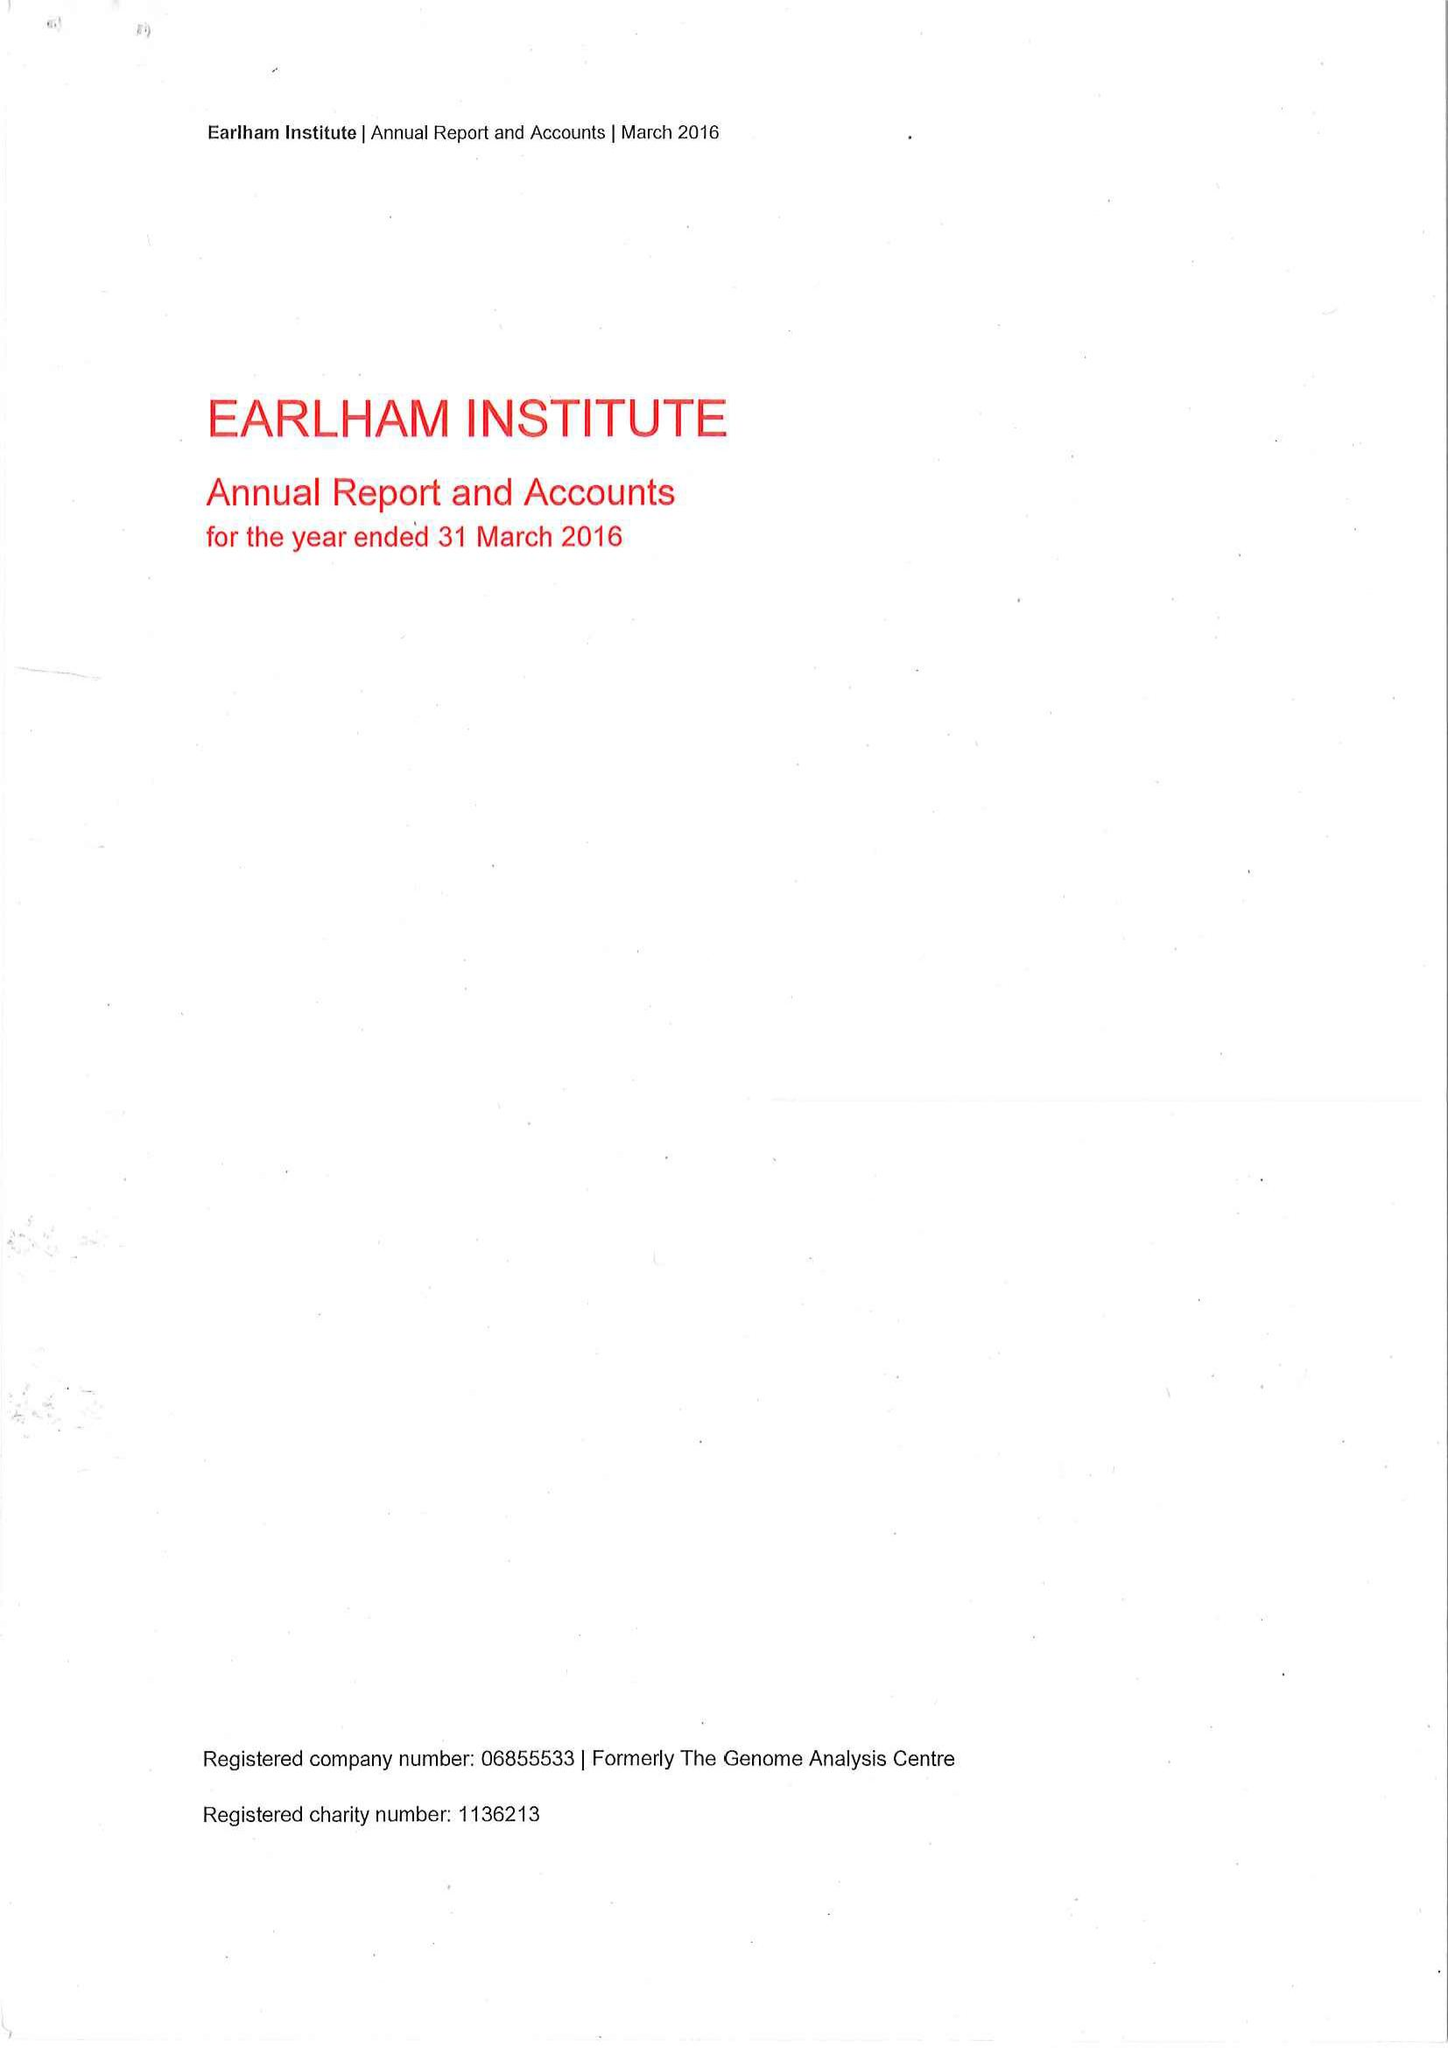What is the value for the address__street_line?
Answer the question using a single word or phrase. None 